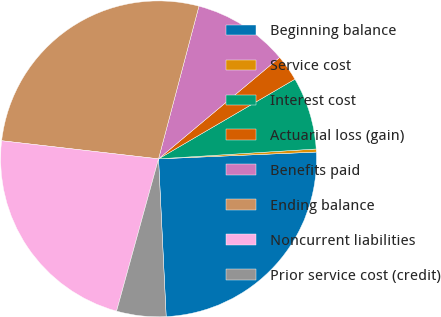<chart> <loc_0><loc_0><loc_500><loc_500><pie_chart><fcel>Beginning balance<fcel>Service cost<fcel>Interest cost<fcel>Actuarial loss (gain)<fcel>Benefits paid<fcel>Ending balance<fcel>Noncurrent liabilities<fcel>Prior service cost (credit)<nl><fcel>24.92%<fcel>0.31%<fcel>7.42%<fcel>2.68%<fcel>9.79%<fcel>27.29%<fcel>22.55%<fcel>5.05%<nl></chart> 